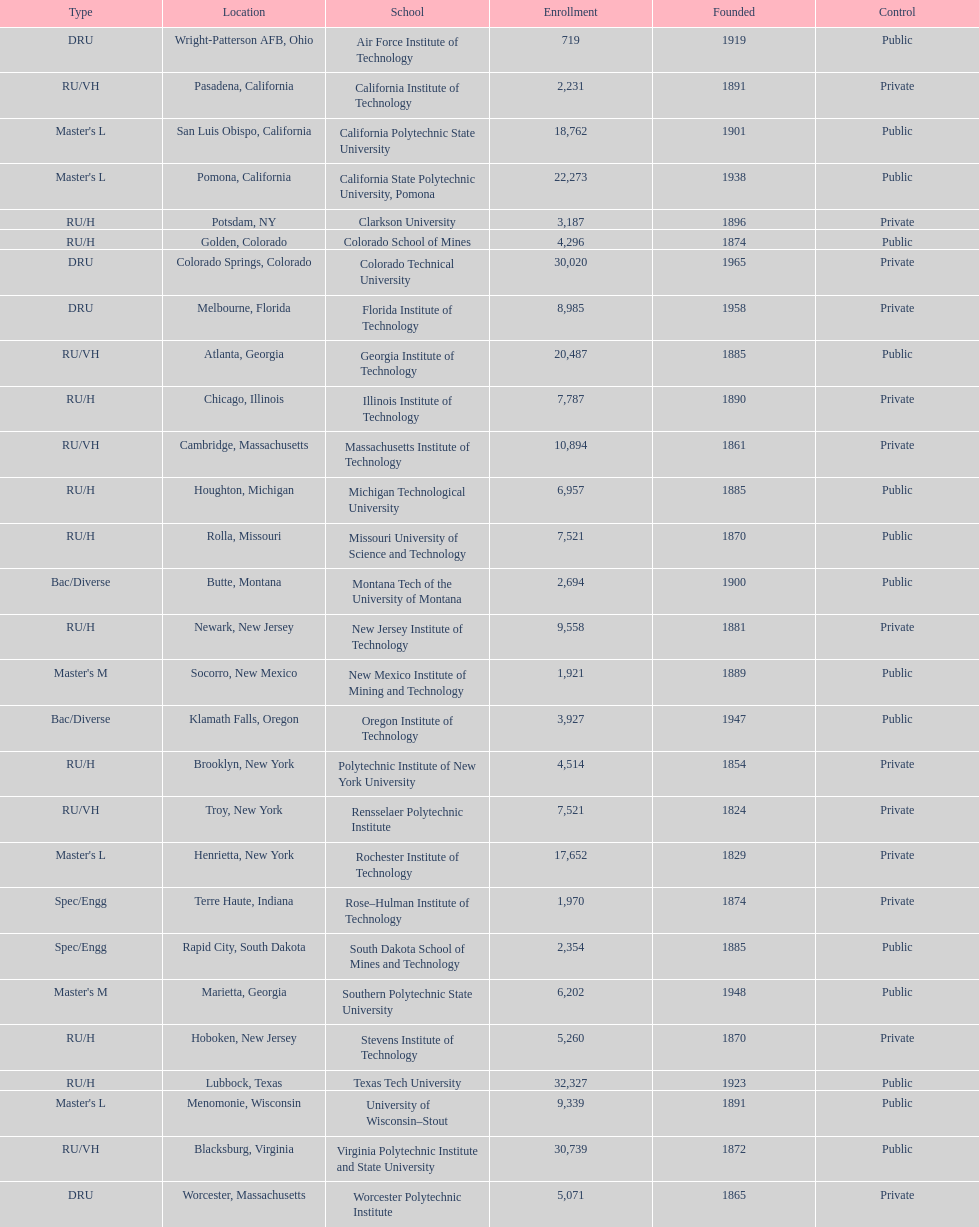Which school had the largest enrollment? Texas Tech University. 